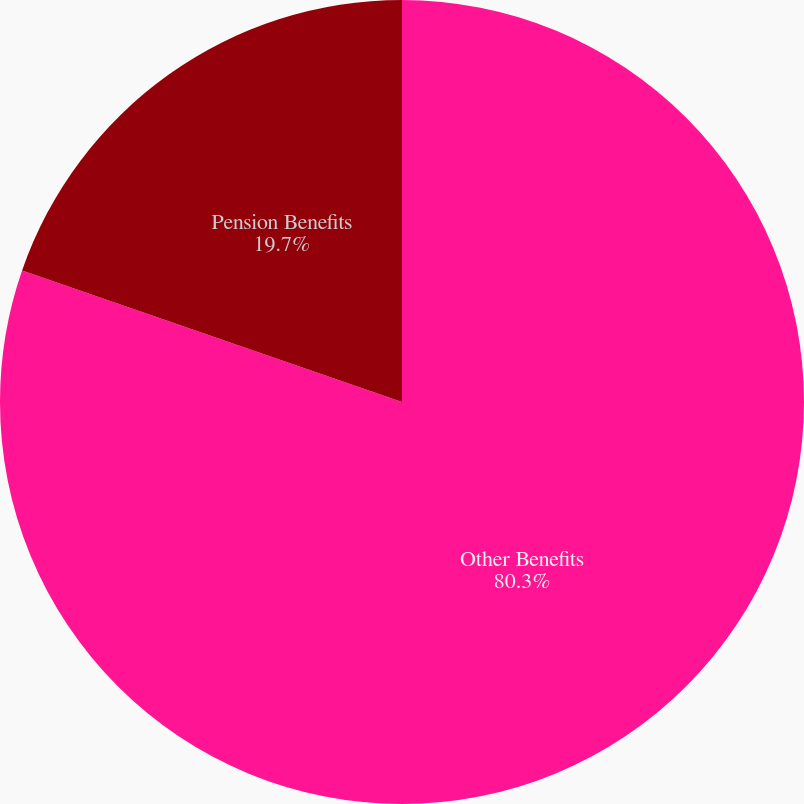<chart> <loc_0><loc_0><loc_500><loc_500><pie_chart><fcel>Other Benefits<fcel>Pension Benefits<nl><fcel>80.3%<fcel>19.7%<nl></chart> 